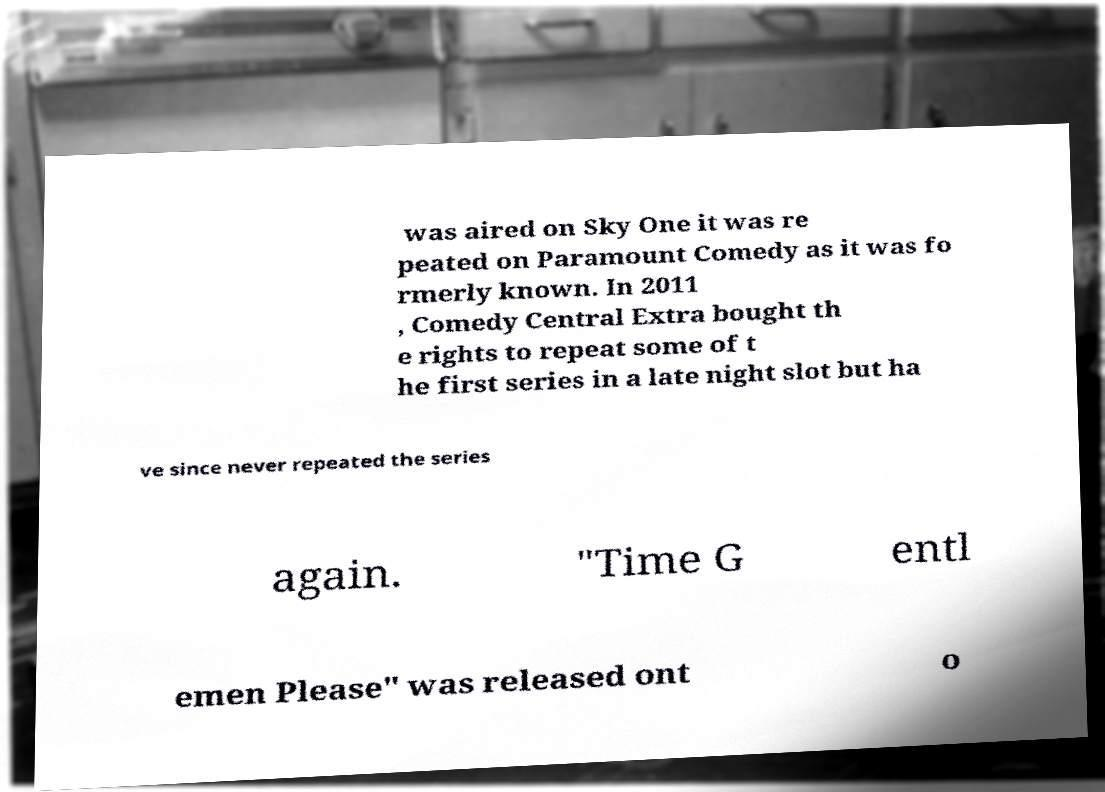Could you extract and type out the text from this image? was aired on Sky One it was re peated on Paramount Comedy as it was fo rmerly known. In 2011 , Comedy Central Extra bought th e rights to repeat some of t he first series in a late night slot but ha ve since never repeated the series again. "Time G entl emen Please" was released ont o 